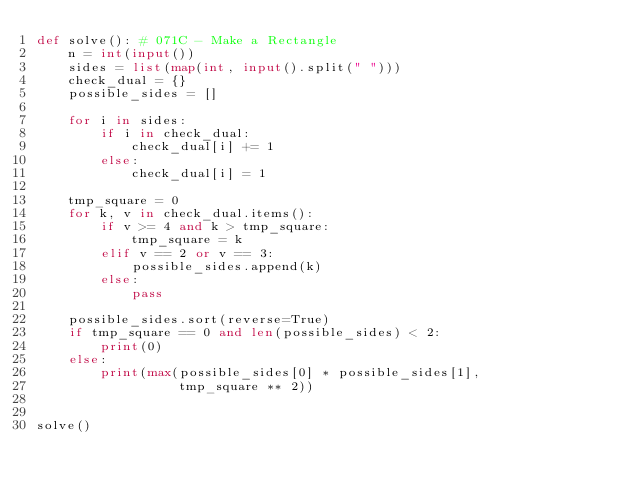Convert code to text. <code><loc_0><loc_0><loc_500><loc_500><_Python_>def solve(): # 071C - Make a Rectangle
    n = int(input())
    sides = list(map(int, input().split(" ")))
    check_dual = {}
    possible_sides = []

    for i in sides:
        if i in check_dual:
            check_dual[i] += 1
        else:
            check_dual[i] = 1

    tmp_square = 0
    for k, v in check_dual.items():
        if v >= 4 and k > tmp_square:
            tmp_square = k
        elif v == 2 or v == 3:
            possible_sides.append(k)
        else:
            pass

    possible_sides.sort(reverse=True)
    if tmp_square == 0 and len(possible_sides) < 2:
        print(0)
    else:
        print(max(possible_sides[0] * possible_sides[1],
                  tmp_square ** 2))


solve()</code> 